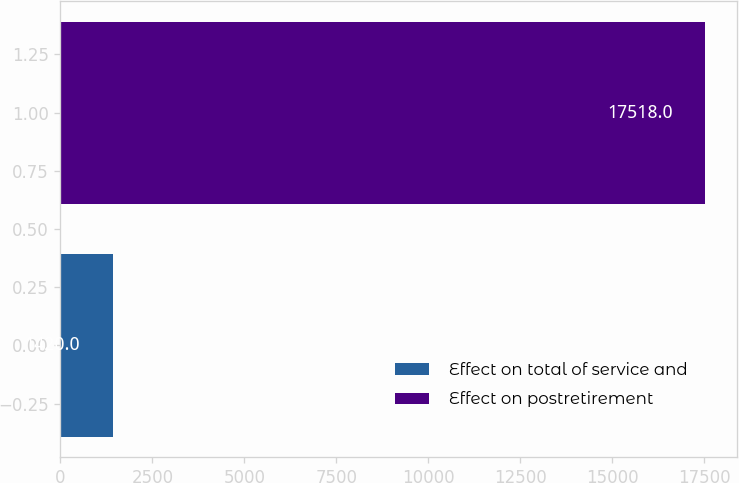Convert chart. <chart><loc_0><loc_0><loc_500><loc_500><bar_chart><fcel>Effect on total of service and<fcel>Effect on postretirement<nl><fcel>1420<fcel>17518<nl></chart> 